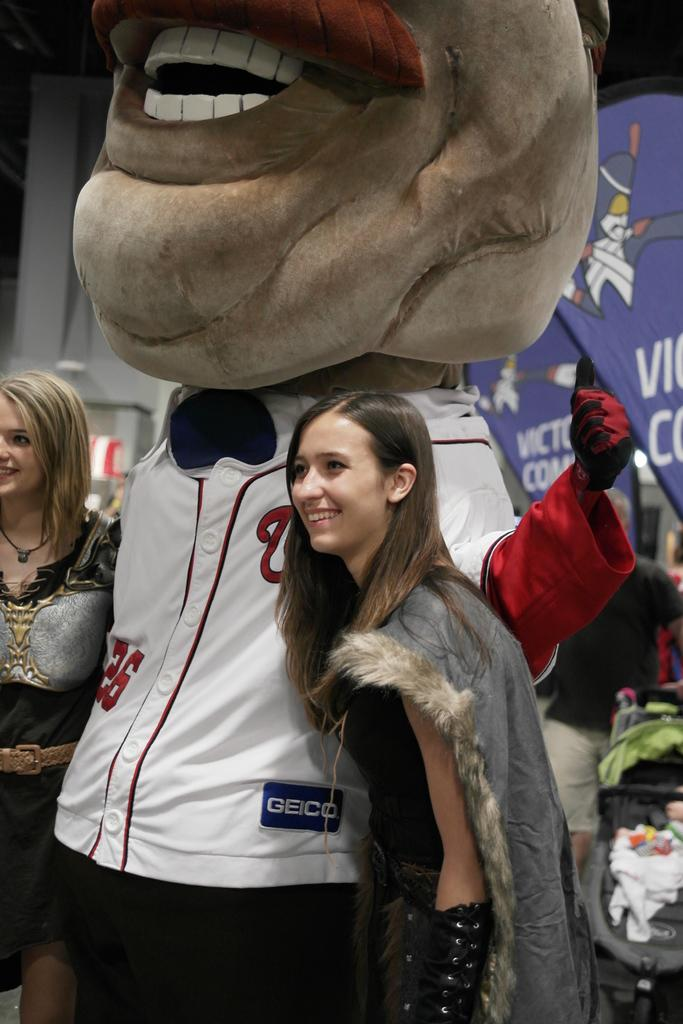<image>
Write a terse but informative summary of the picture. Woman posing next to a mascot wearing a number 26 jersey. 